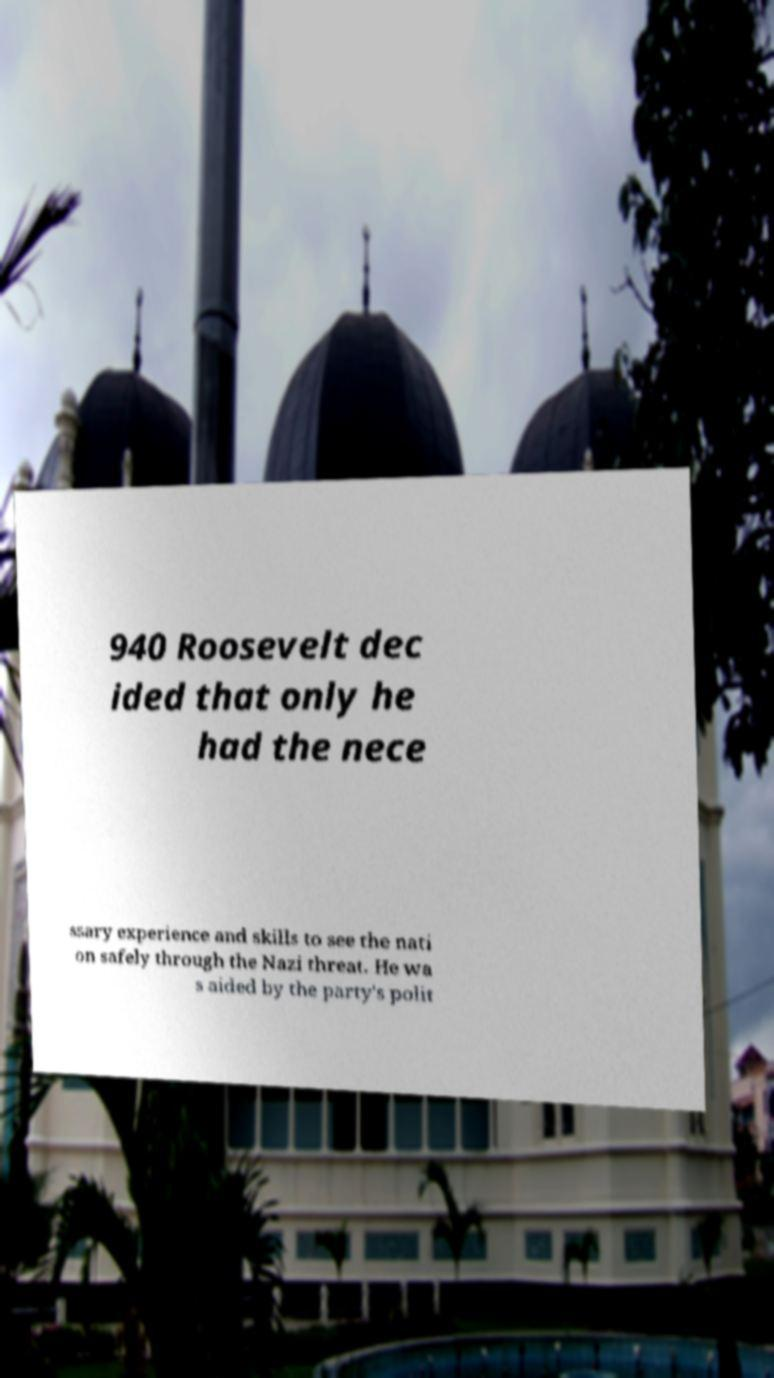Can you accurately transcribe the text from the provided image for me? 940 Roosevelt dec ided that only he had the nece ssary experience and skills to see the nati on safely through the Nazi threat. He wa s aided by the party's polit 